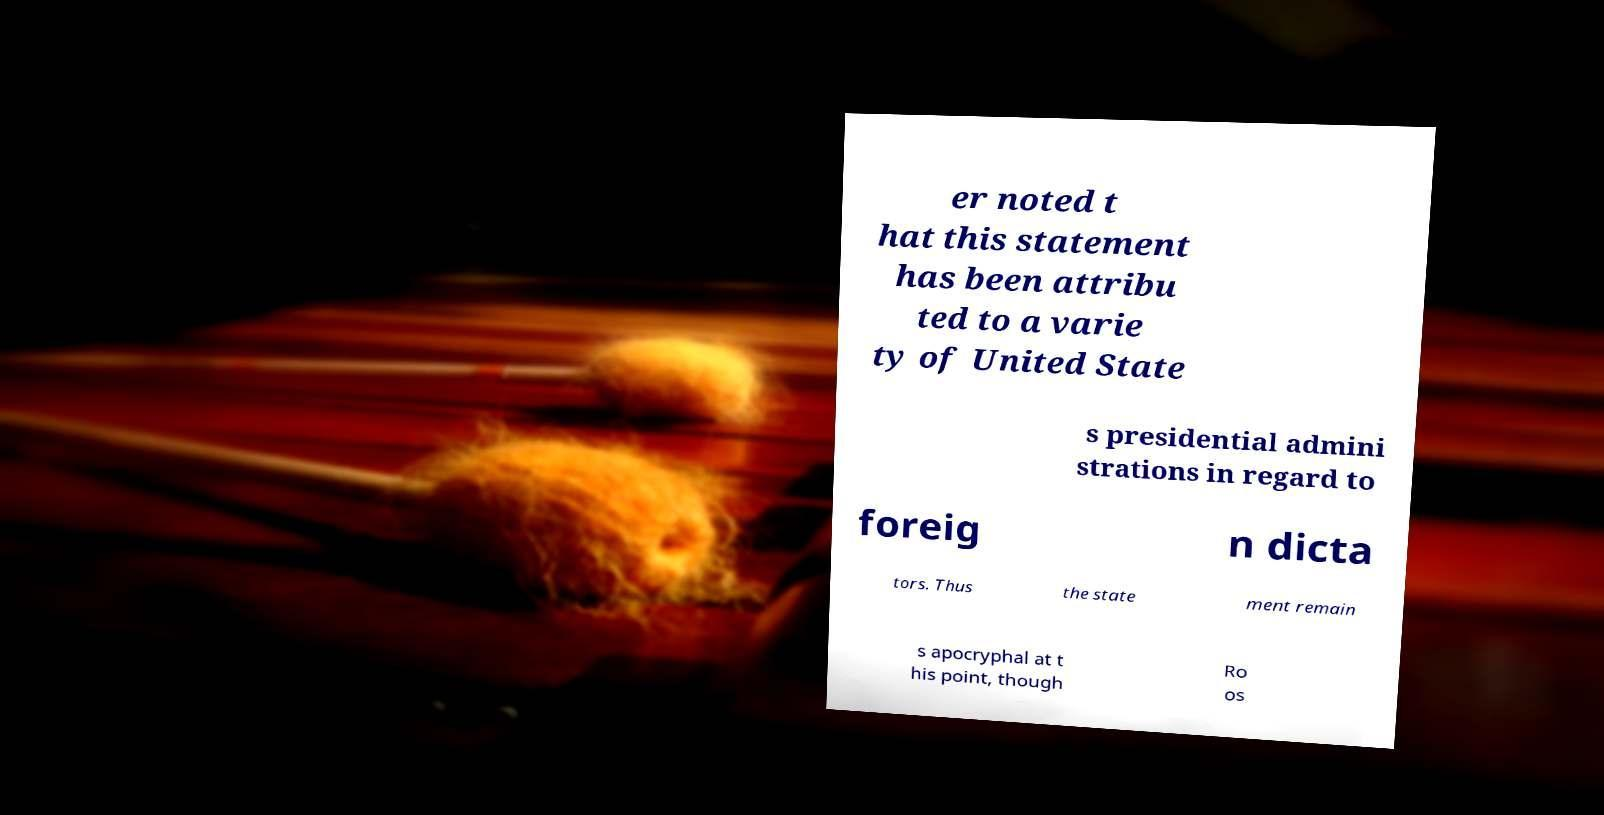Can you read and provide the text displayed in the image?This photo seems to have some interesting text. Can you extract and type it out for me? er noted t hat this statement has been attribu ted to a varie ty of United State s presidential admini strations in regard to foreig n dicta tors. Thus the state ment remain s apocryphal at t his point, though Ro os 